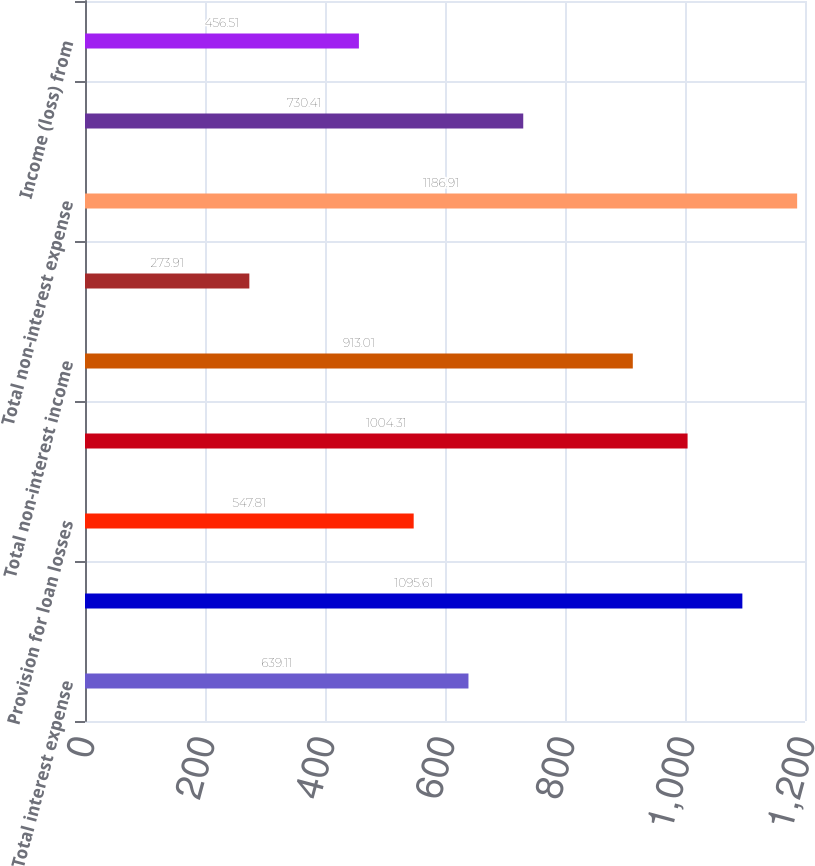Convert chart. <chart><loc_0><loc_0><loc_500><loc_500><bar_chart><fcel>Total interest expense<fcel>Net interest income<fcel>Provision for loan losses<fcel>Net interest income after<fcel>Total non-interest income<fcel>Securities gains (losses) net<fcel>Total non-interest expense<fcel>Income (loss) from continuing<fcel>Income (loss) from<nl><fcel>639.11<fcel>1095.61<fcel>547.81<fcel>1004.31<fcel>913.01<fcel>273.91<fcel>1186.91<fcel>730.41<fcel>456.51<nl></chart> 